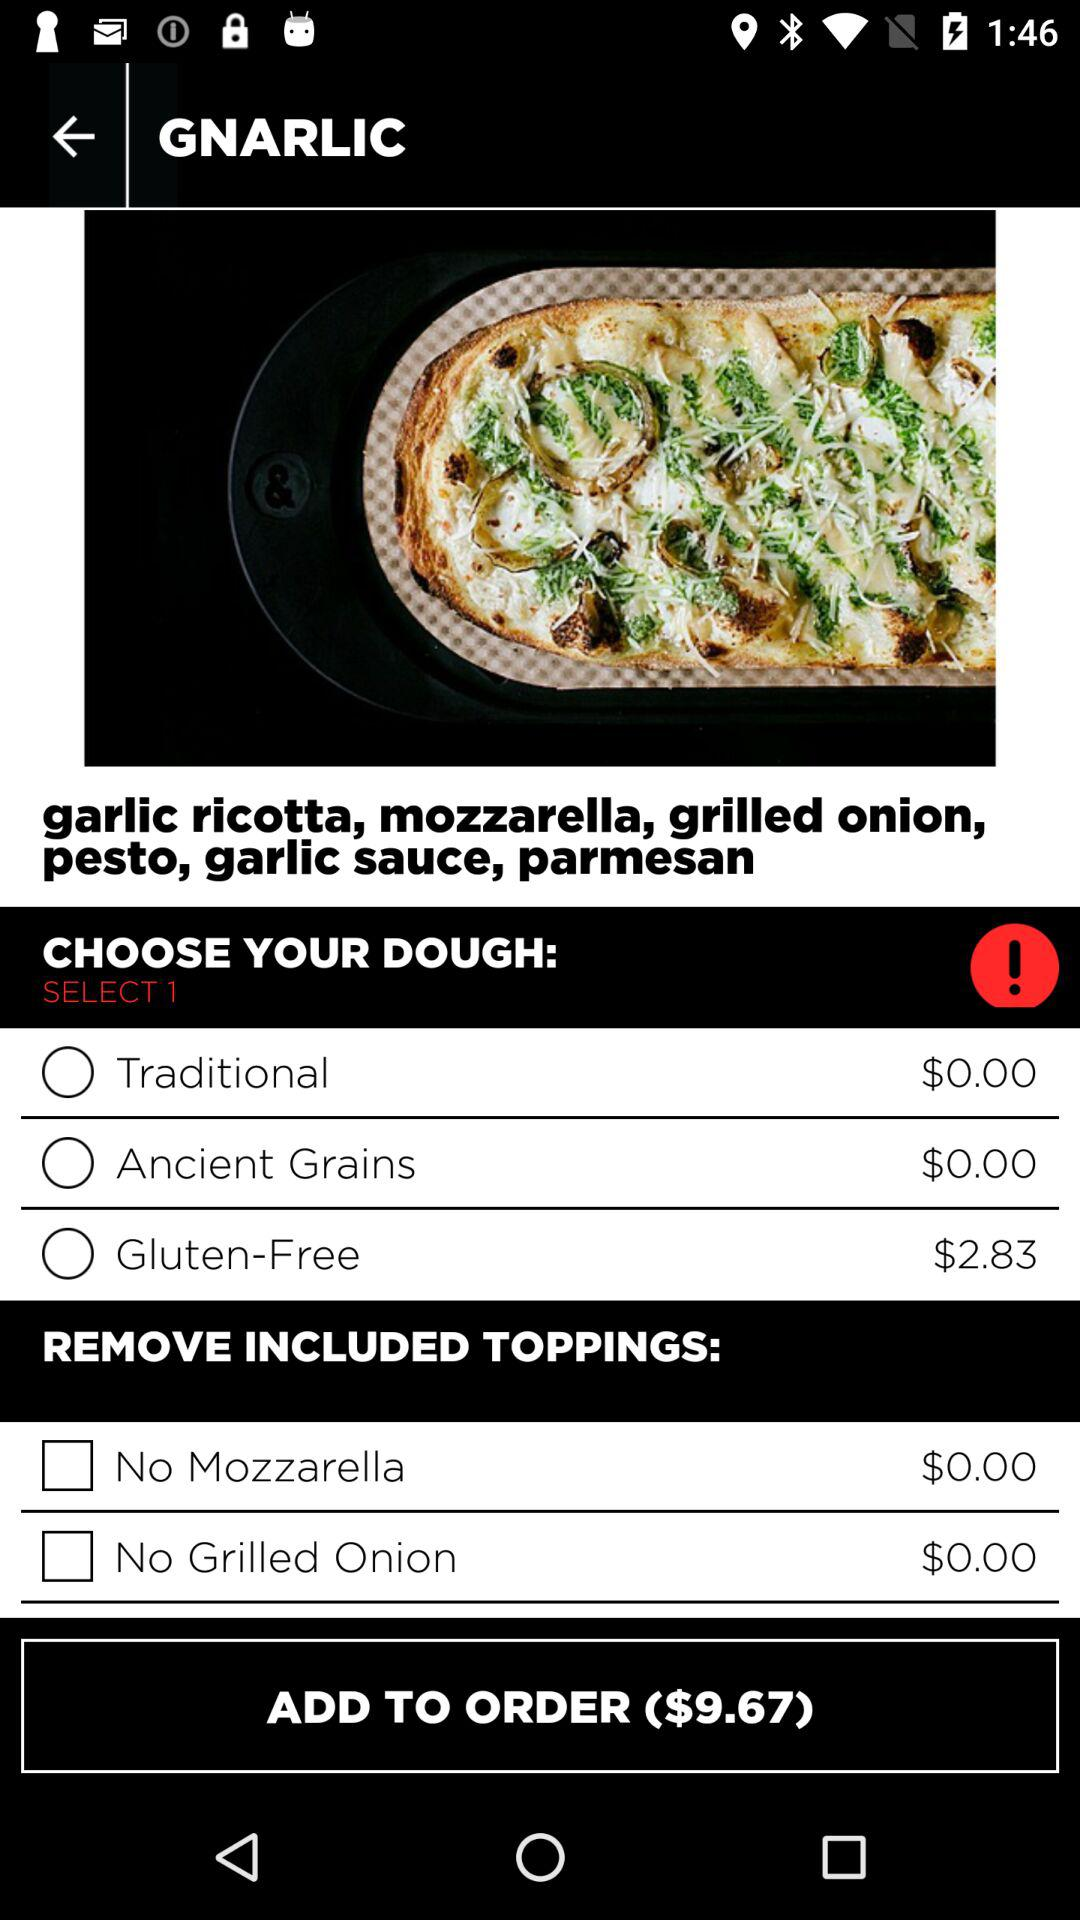What is the name of the dish? The name of the dish is "GNARLIC". 